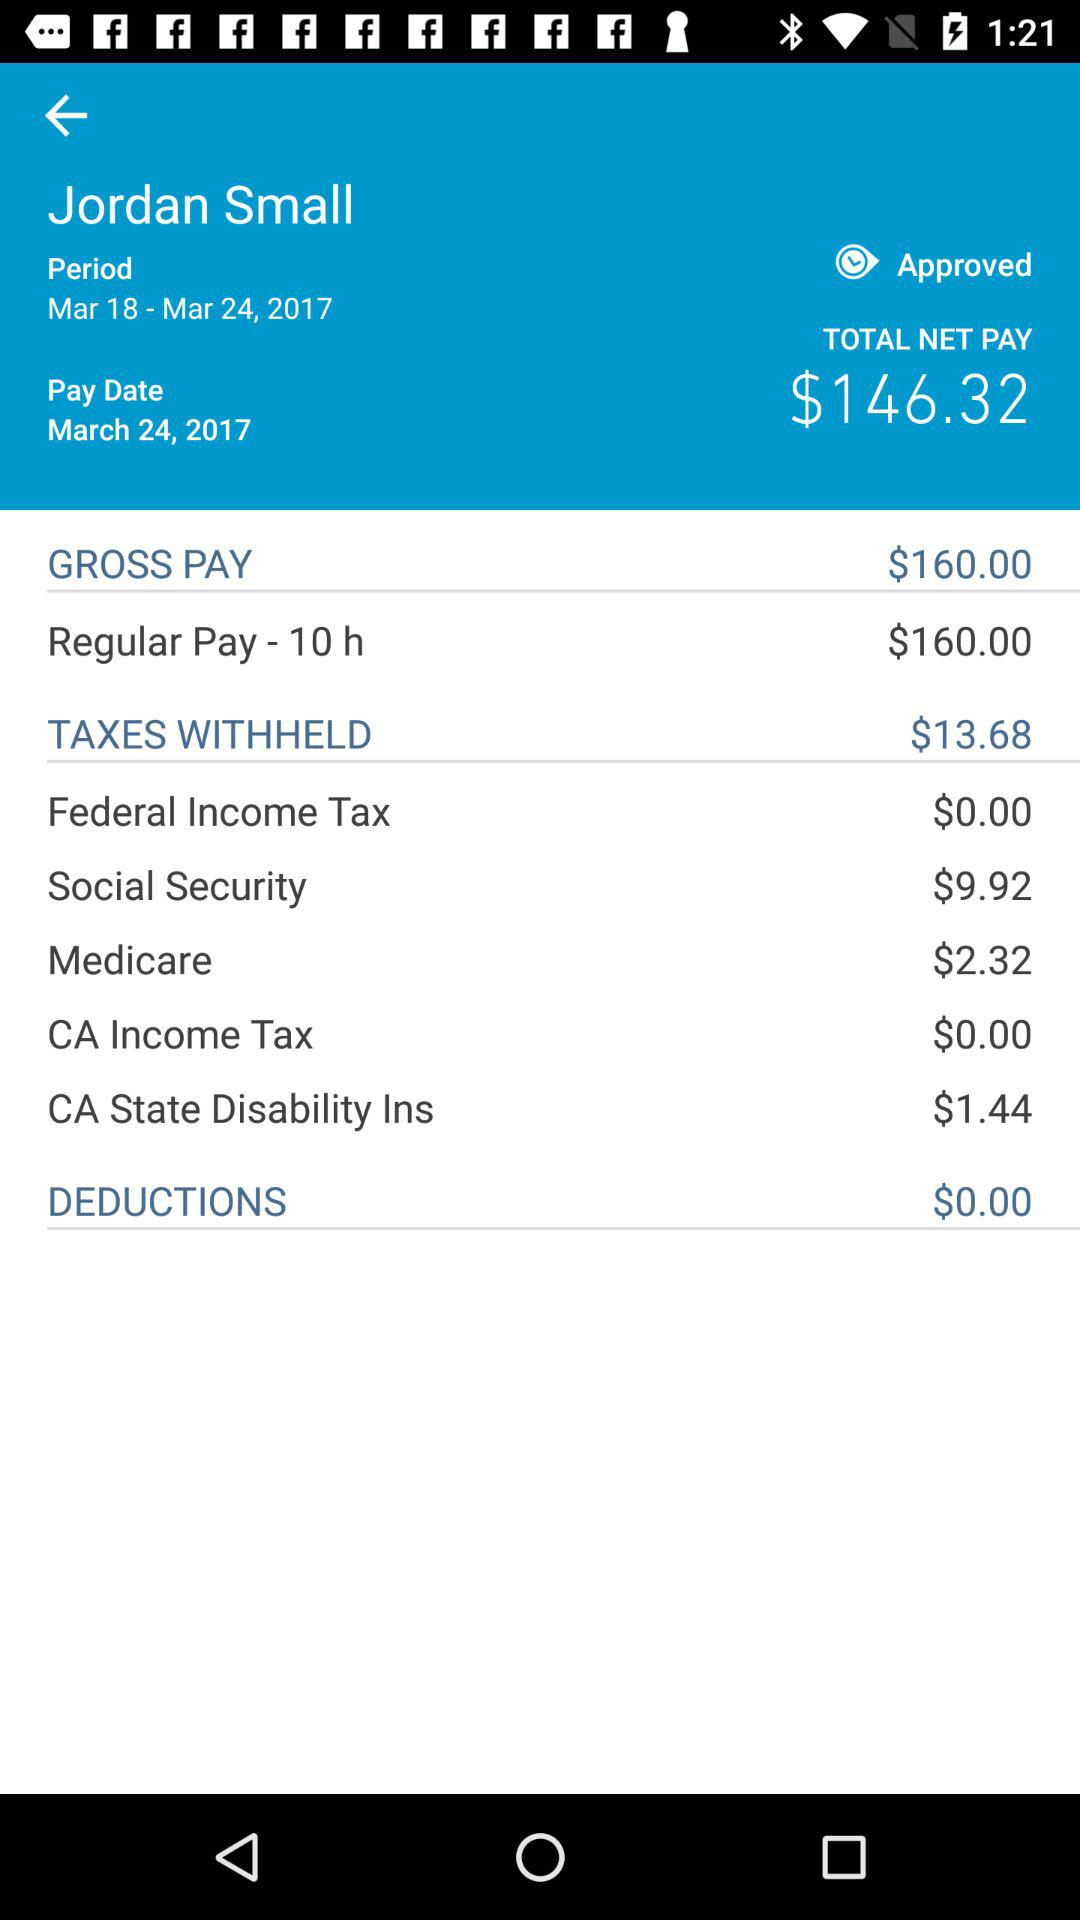What is the pay date of Jordan Small? The pay date of Jordan Small is March 24, 2017. 